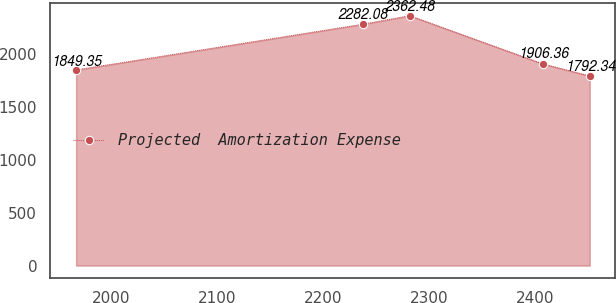Convert chart. <chart><loc_0><loc_0><loc_500><loc_500><line_chart><ecel><fcel>Projected  Amortization Expense<nl><fcel>1966.58<fcel>1849.35<nl><fcel>2237.61<fcel>2282.08<nl><fcel>2281.83<fcel>2362.48<nl><fcel>2407.71<fcel>1906.36<nl><fcel>2451.93<fcel>1792.34<nl></chart> 